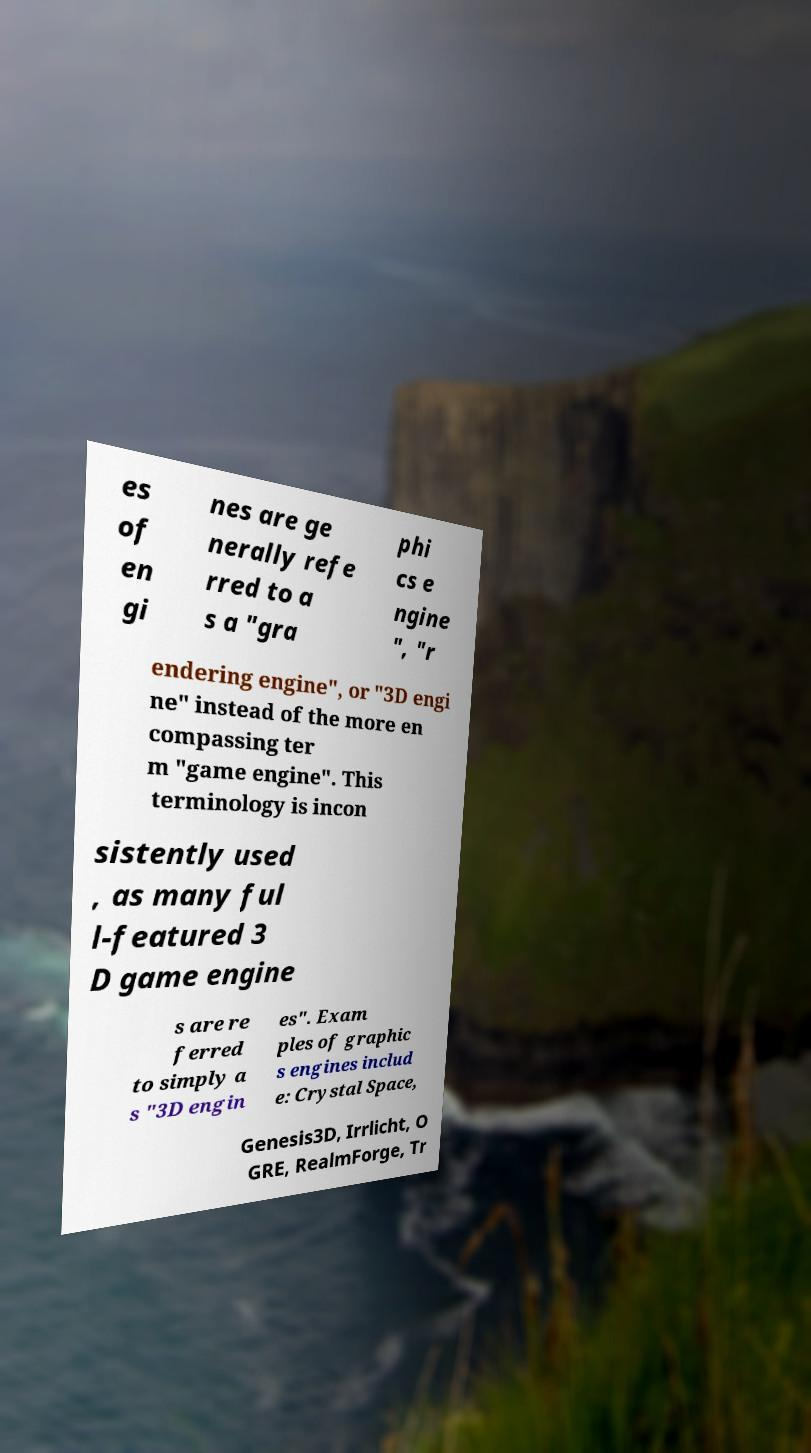Could you extract and type out the text from this image? es of en gi nes are ge nerally refe rred to a s a "gra phi cs e ngine ", "r endering engine", or "3D engi ne" instead of the more en compassing ter m "game engine". This terminology is incon sistently used , as many ful l-featured 3 D game engine s are re ferred to simply a s "3D engin es". Exam ples of graphic s engines includ e: Crystal Space, Genesis3D, Irrlicht, O GRE, RealmForge, Tr 